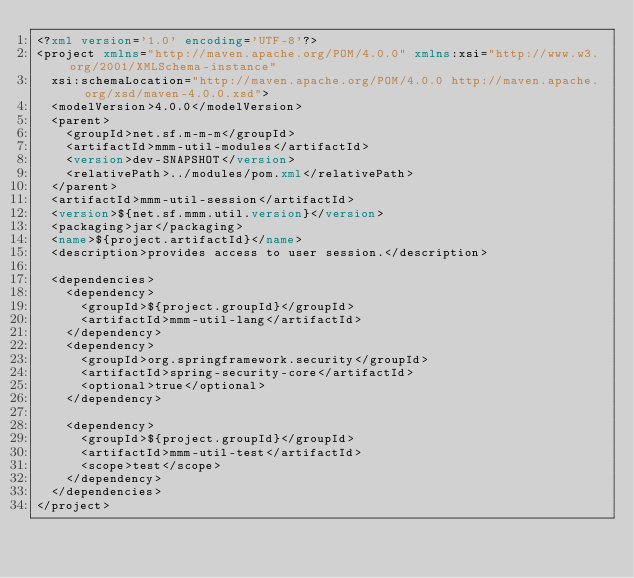<code> <loc_0><loc_0><loc_500><loc_500><_XML_><?xml version='1.0' encoding='UTF-8'?>
<project xmlns="http://maven.apache.org/POM/4.0.0" xmlns:xsi="http://www.w3.org/2001/XMLSchema-instance"
  xsi:schemaLocation="http://maven.apache.org/POM/4.0.0 http://maven.apache.org/xsd/maven-4.0.0.xsd">
  <modelVersion>4.0.0</modelVersion>
  <parent>
    <groupId>net.sf.m-m-m</groupId>
    <artifactId>mmm-util-modules</artifactId>
    <version>dev-SNAPSHOT</version>
    <relativePath>../modules/pom.xml</relativePath>
  </parent>
  <artifactId>mmm-util-session</artifactId>
  <version>${net.sf.mmm.util.version}</version>
  <packaging>jar</packaging>
  <name>${project.artifactId}</name>
  <description>provides access to user session.</description>

  <dependencies>
    <dependency>
      <groupId>${project.groupId}</groupId>
      <artifactId>mmm-util-lang</artifactId>
    </dependency>
    <dependency>
      <groupId>org.springframework.security</groupId>
      <artifactId>spring-security-core</artifactId>
      <optional>true</optional>
    </dependency>

    <dependency>
      <groupId>${project.groupId}</groupId>
      <artifactId>mmm-util-test</artifactId>
      <scope>test</scope>
    </dependency>
  </dependencies>
</project>
</code> 